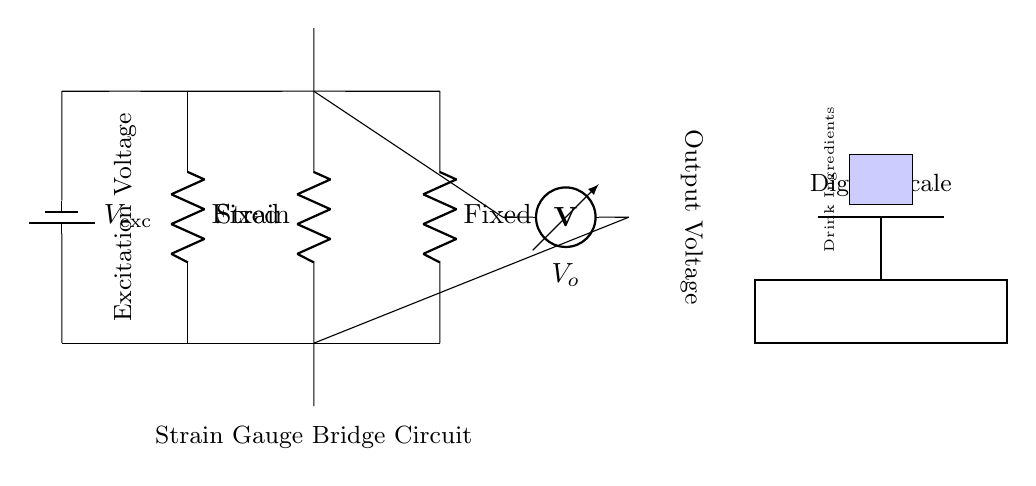What voltage is supplied to the circuit? The voltage supplied to the circuit is represented by the label $V_{\text{exc}}$, which indicates the excitation voltage for the strain gauge bridge circuit.
Answer: Excitation Voltage How many resistors are in the bridge circuit? The bridge circuit contains three resistors: one fixed resistor $R_1$, one fixed resistor $R_3$, and one strain gauge $R_2$.
Answer: Three What is the role of the strain gauge in this circuit? The strain gauge $R_2$ in this circuit is responsible for measuring the weight of the drink ingredients by changing its resistance according to the applied strain (weight).
Answer: Measure weight How does the output voltage relate to the resistance changes? The output voltage $V_o$ is influenced by the balance of the resistances in the bridge circuit; changes in the resistance of $R_2$ will cause a change in output voltage, indicating the weight of the ingredients.
Answer: Influenced by resistance What component converts the resistance changes to voltage? The output voltage is measured across the voltmeter connected to the bridge, which converts resistance changes into a measurable voltage output.
Answer: Voltmeter Which resistors are fixed in this circuit? The resistors $R_1$ and $R_3$ are labeled as fixed resistors, indicating they do not change their resistance value during operation.
Answer: R1 and R3 